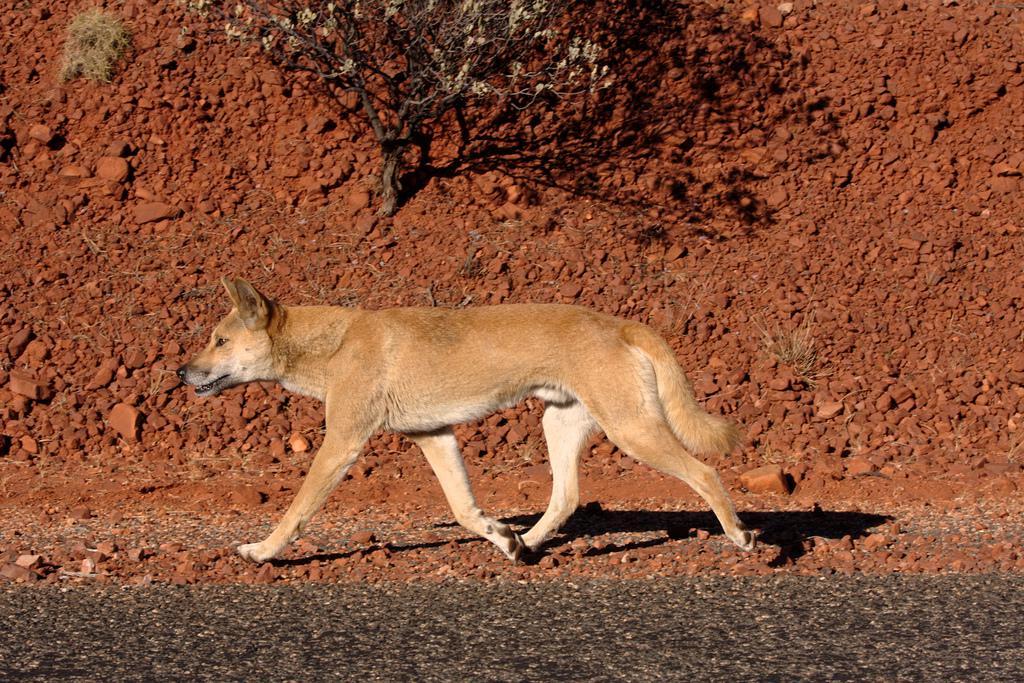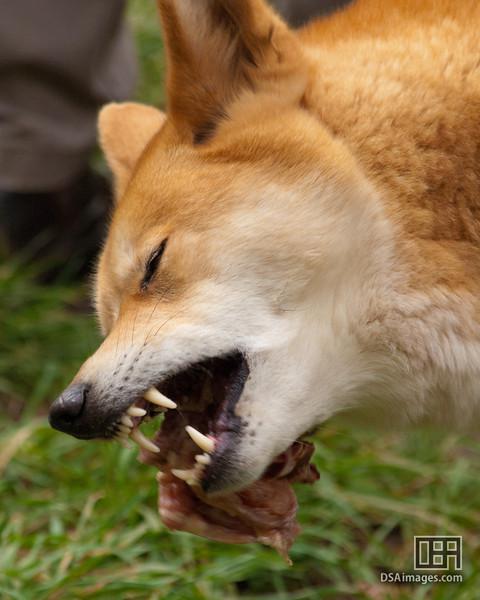The first image is the image on the left, the second image is the image on the right. For the images shown, is this caption "An image shows one wild dog walking leftward across green grass." true? Answer yes or no. No. The first image is the image on the left, the second image is the image on the right. Given the left and right images, does the statement "A dog is walking through the grass in one of the images." hold true? Answer yes or no. No. 